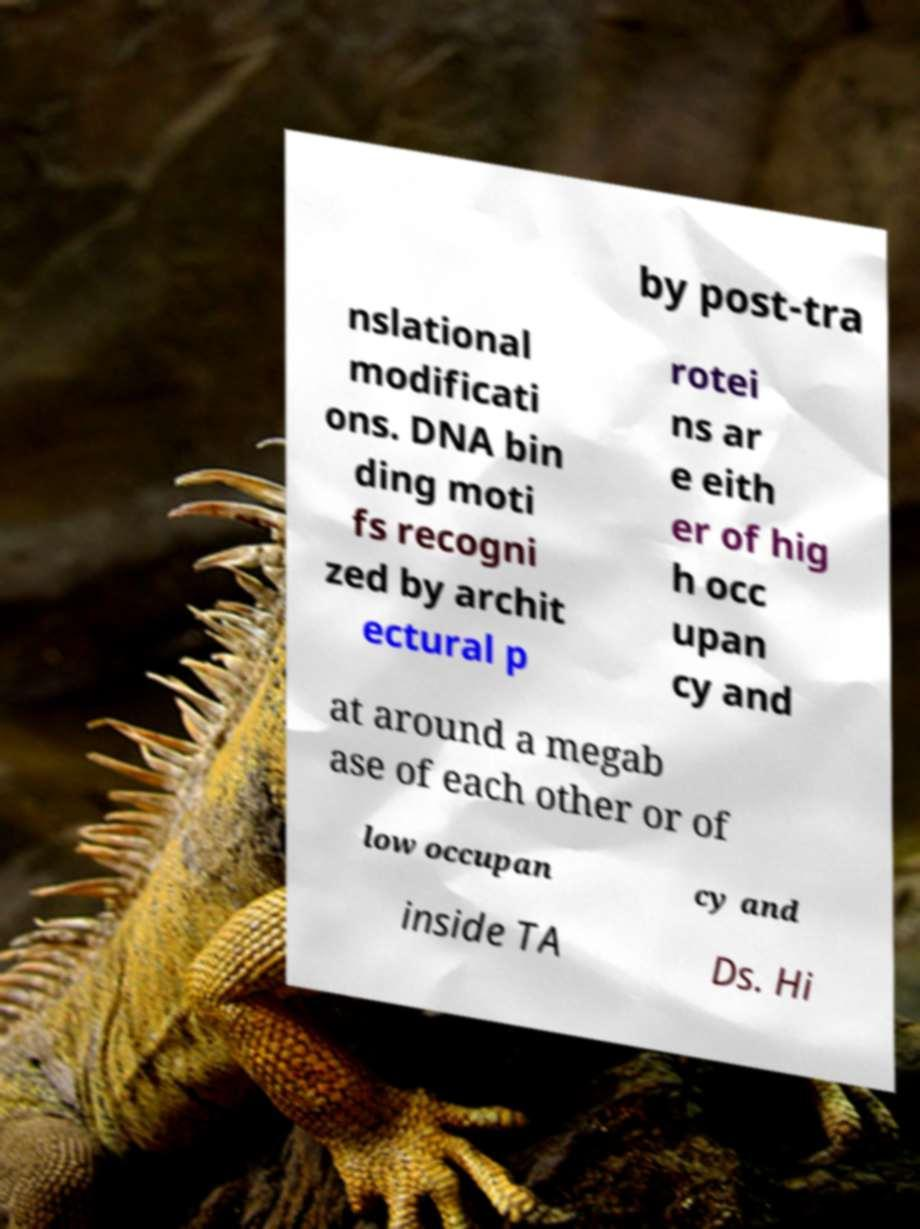Can you read and provide the text displayed in the image?This photo seems to have some interesting text. Can you extract and type it out for me? by post-tra nslational modificati ons. DNA bin ding moti fs recogni zed by archit ectural p rotei ns ar e eith er of hig h occ upan cy and at around a megab ase of each other or of low occupan cy and inside TA Ds. Hi 